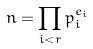<formula> <loc_0><loc_0><loc_500><loc_500>n = \prod _ { i < r } p _ { i } ^ { e _ { i } }</formula> 